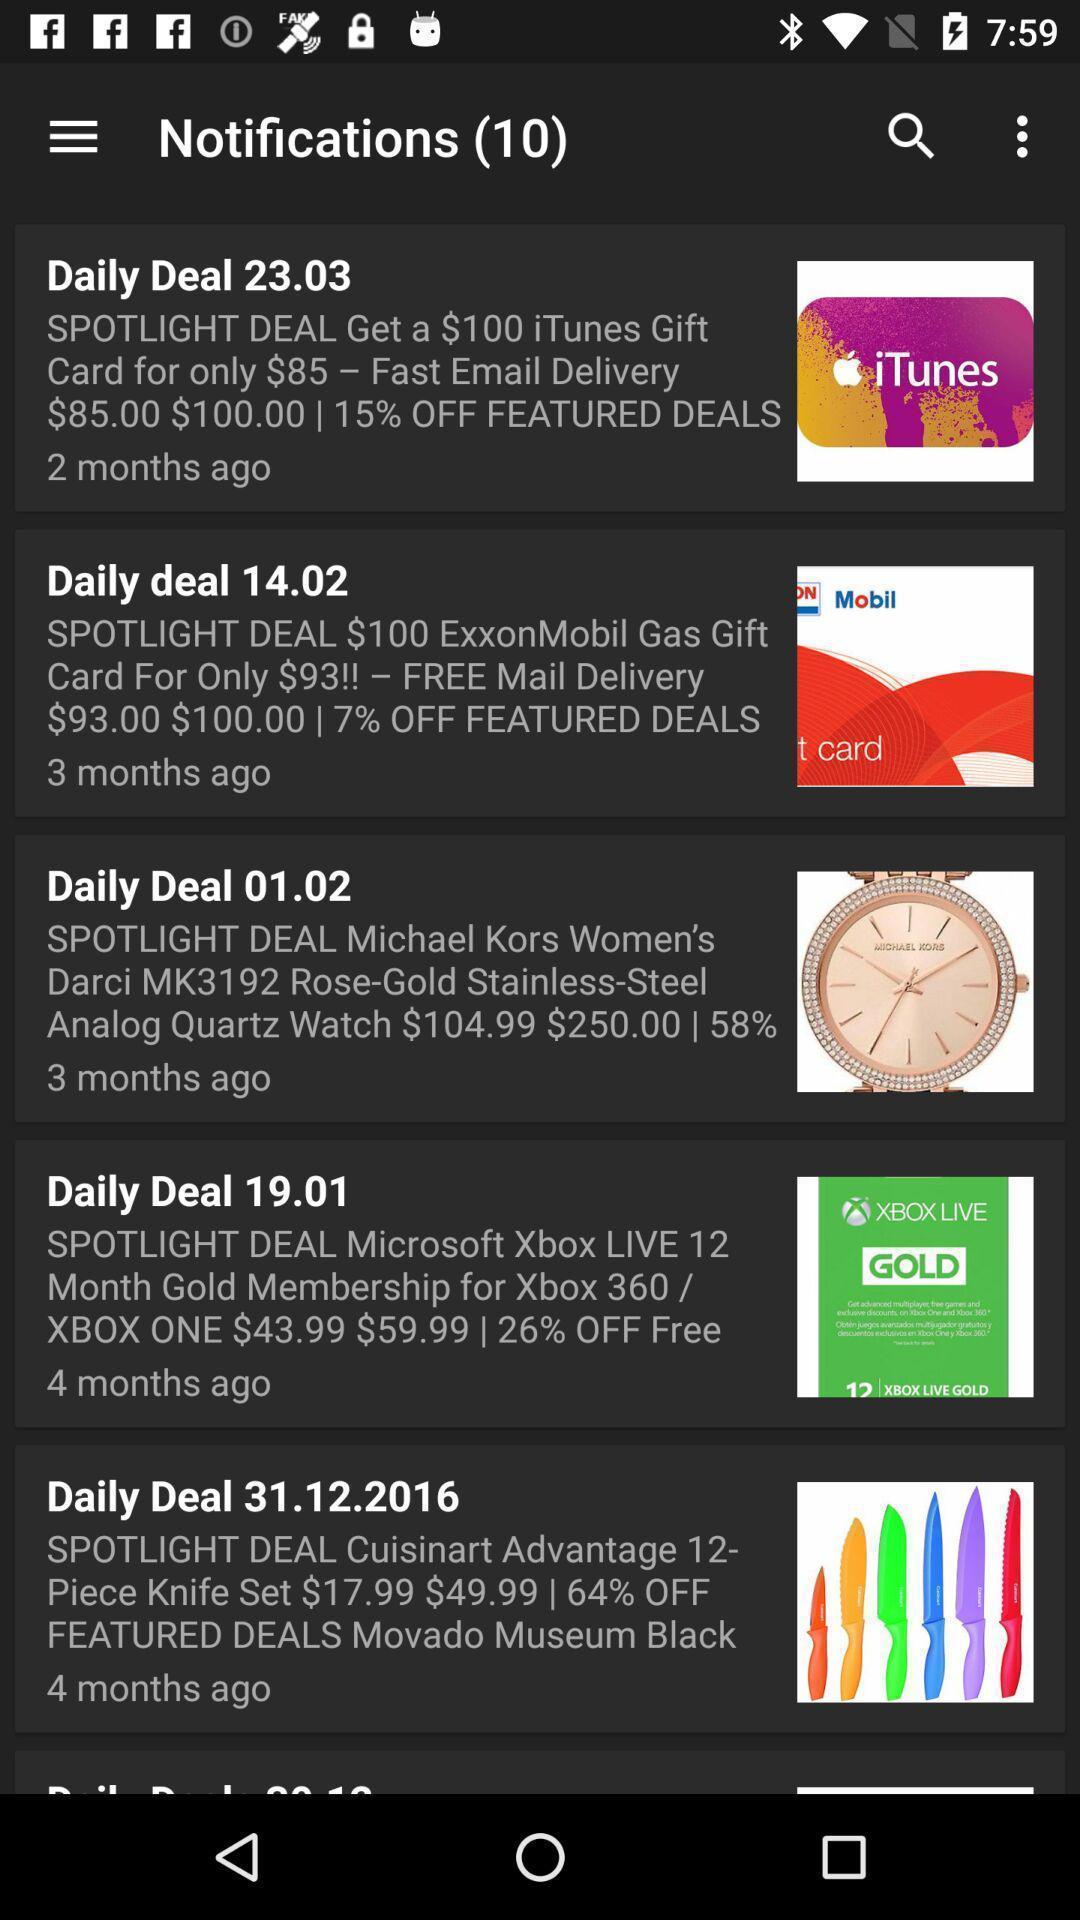What is the overall content of this screenshot? Screen displaying the list in the notifications page. 